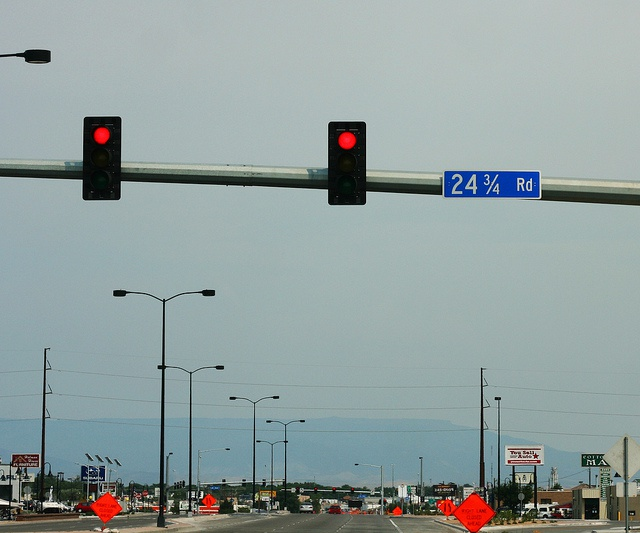Describe the objects in this image and their specific colors. I can see traffic light in darkgray, black, red, and gray tones, traffic light in darkgray, black, red, and gray tones, car in darkgray, black, gray, and lightgray tones, car in darkgray, black, gray, and maroon tones, and car in darkgray, black, gray, and darkgreen tones in this image. 